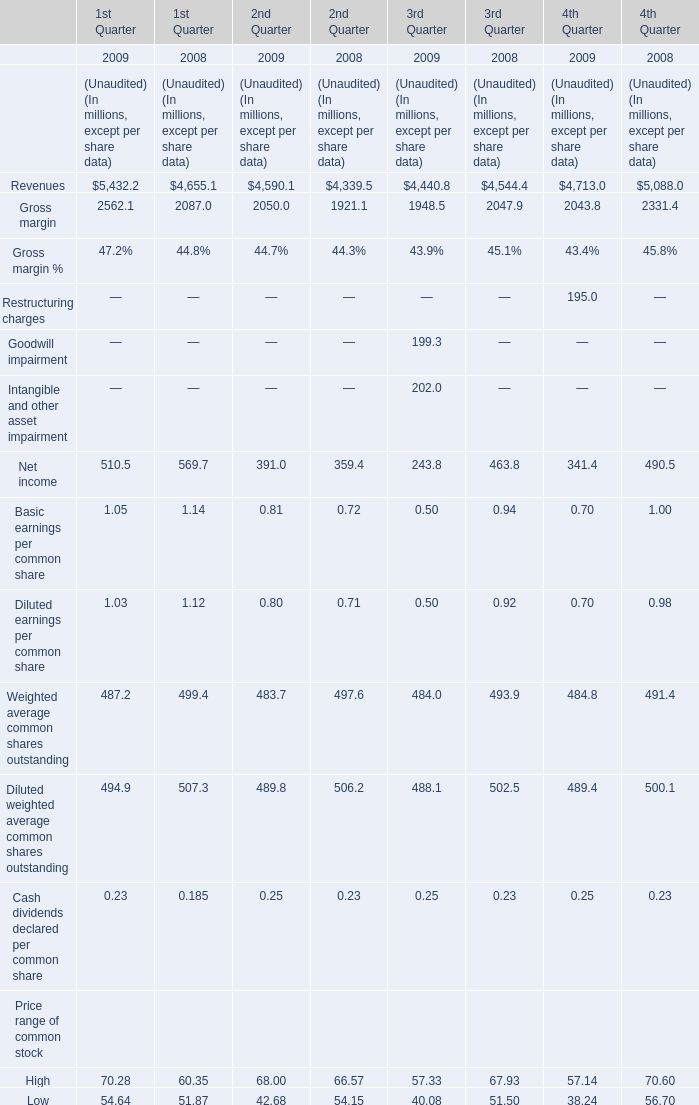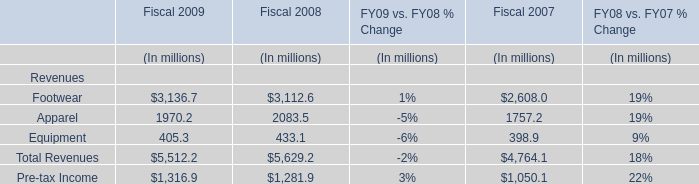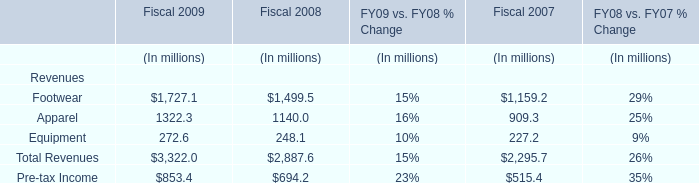What is the growing rate of Weighted average common shares outstanding for 2nd Quarter in the year with the most Net income for 2nd Quarter? 
Computations: ((483.7 - 497.6) / 497.6)
Answer: -0.02793. 